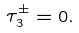Convert formula to latex. <formula><loc_0><loc_0><loc_500><loc_500>\tau _ { 3 } ^ { \pm } = 0 .</formula> 